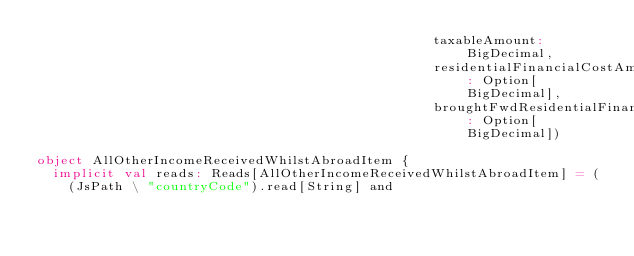<code> <loc_0><loc_0><loc_500><loc_500><_Scala_>                                                  taxableAmount: BigDecimal,
                                                  residentialFinancialCostAmount: Option[BigDecimal],
                                                  broughtFwdResidentialFinancialCostAmount: Option[BigDecimal])

object AllOtherIncomeReceivedWhilstAbroadItem {
  implicit val reads: Reads[AllOtherIncomeReceivedWhilstAbroadItem] = (
    (JsPath \ "countryCode").read[String] and</code> 